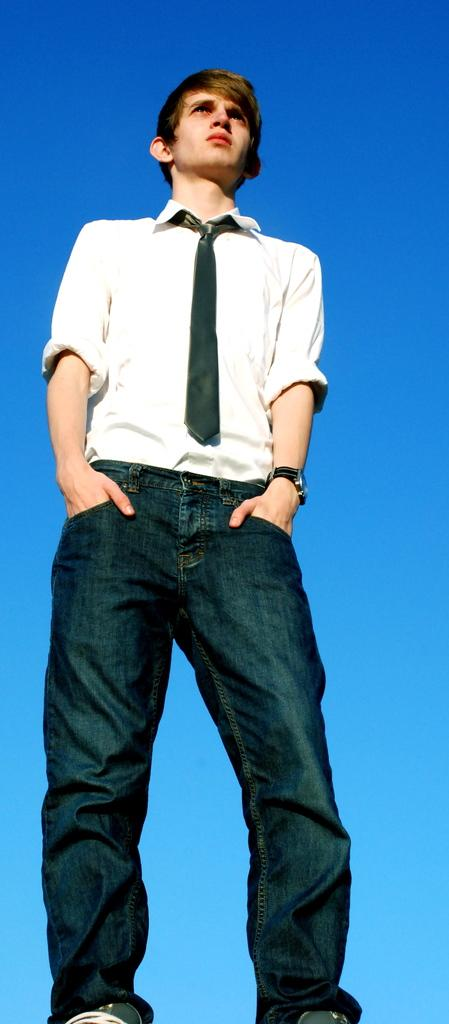Who is present in the image? There is a man in the image. What is the man wearing? The man is wearing a white shirt and jeans. What is the man doing in the image? The man is standing. What can be seen in the background of the image? There is a sky visible in the background of the image. What type of paste is the man using to build the rock structure in the image? There is no paste or rock structure present in the image; it features a man wearing a white shirt and jeans, standing with a sky visible in the background. 